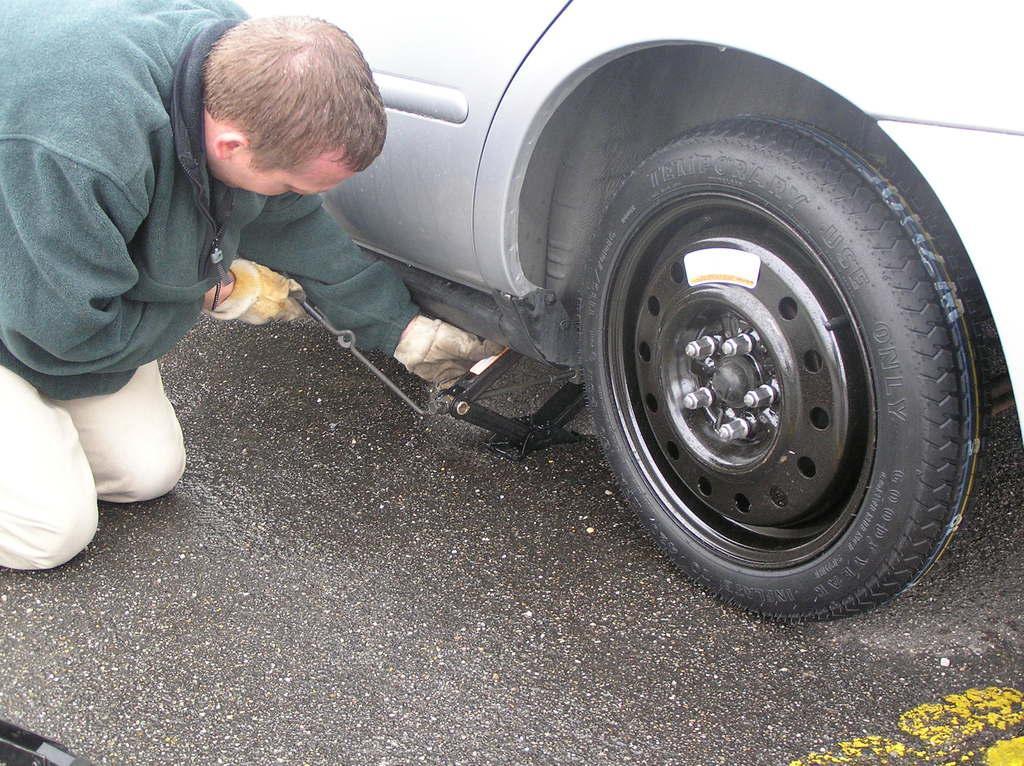Could you give a brief overview of what you see in this image? In this image there is a person kneeling down on the road and trying to lift the car using the car gauge. At the bottom there is road. 